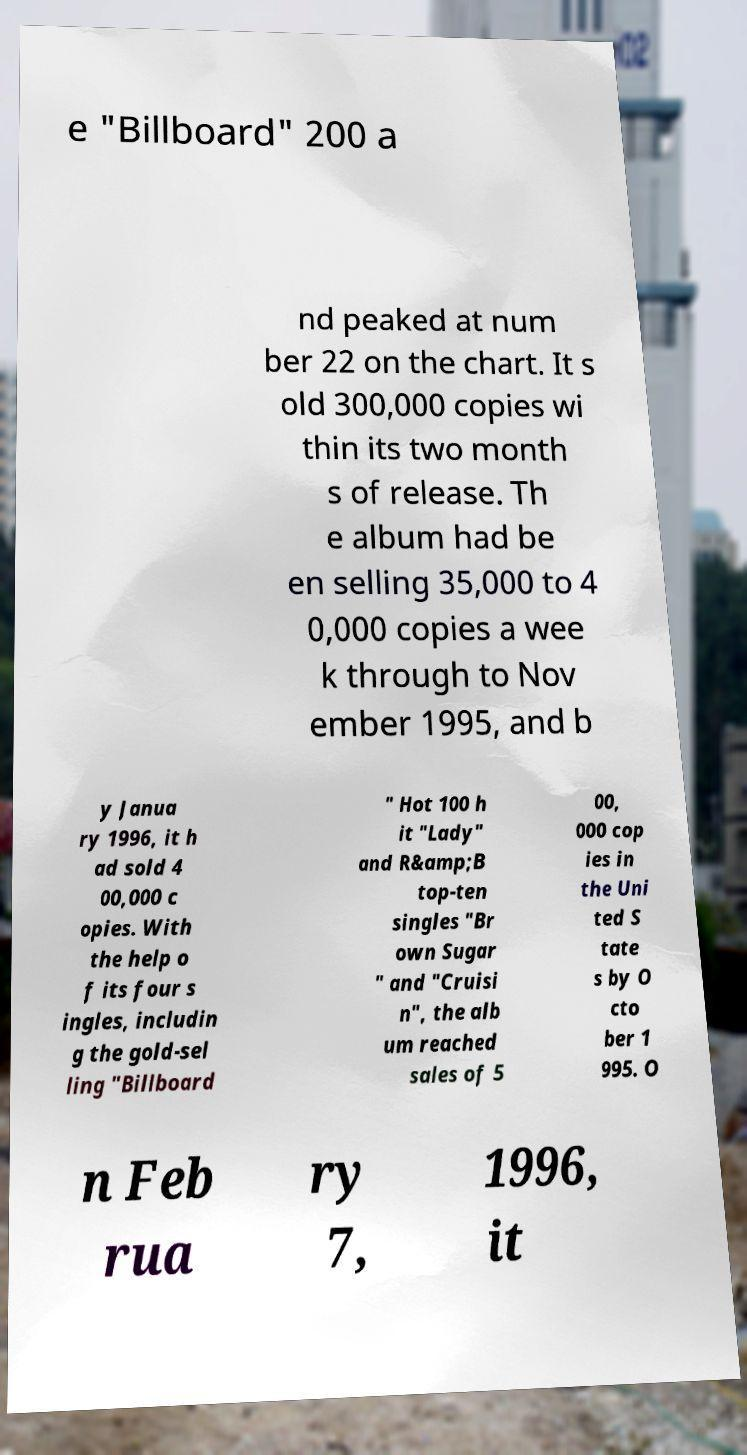Can you accurately transcribe the text from the provided image for me? e "Billboard" 200 a nd peaked at num ber 22 on the chart. It s old 300,000 copies wi thin its two month s of release. Th e album had be en selling 35,000 to 4 0,000 copies a wee k through to Nov ember 1995, and b y Janua ry 1996, it h ad sold 4 00,000 c opies. With the help o f its four s ingles, includin g the gold-sel ling "Billboard " Hot 100 h it "Lady" and R&amp;B top-ten singles "Br own Sugar " and "Cruisi n", the alb um reached sales of 5 00, 000 cop ies in the Uni ted S tate s by O cto ber 1 995. O n Feb rua ry 7, 1996, it 